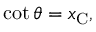Convert formula to latex. <formula><loc_0><loc_0><loc_500><loc_500>\cot \theta = x _ { C } ,</formula> 